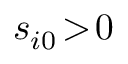<formula> <loc_0><loc_0><loc_500><loc_500>s _ { i 0 } \, > \, 0</formula> 